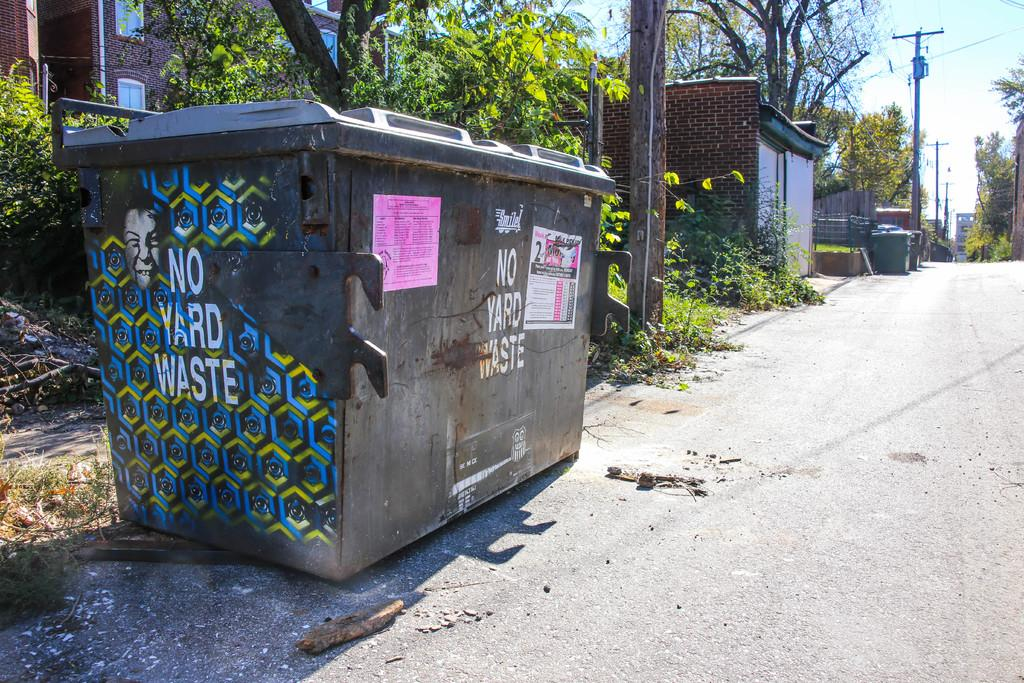<image>
Offer a succinct explanation of the picture presented. A brown dumpster sits on a road, but it is not for yard waste. 